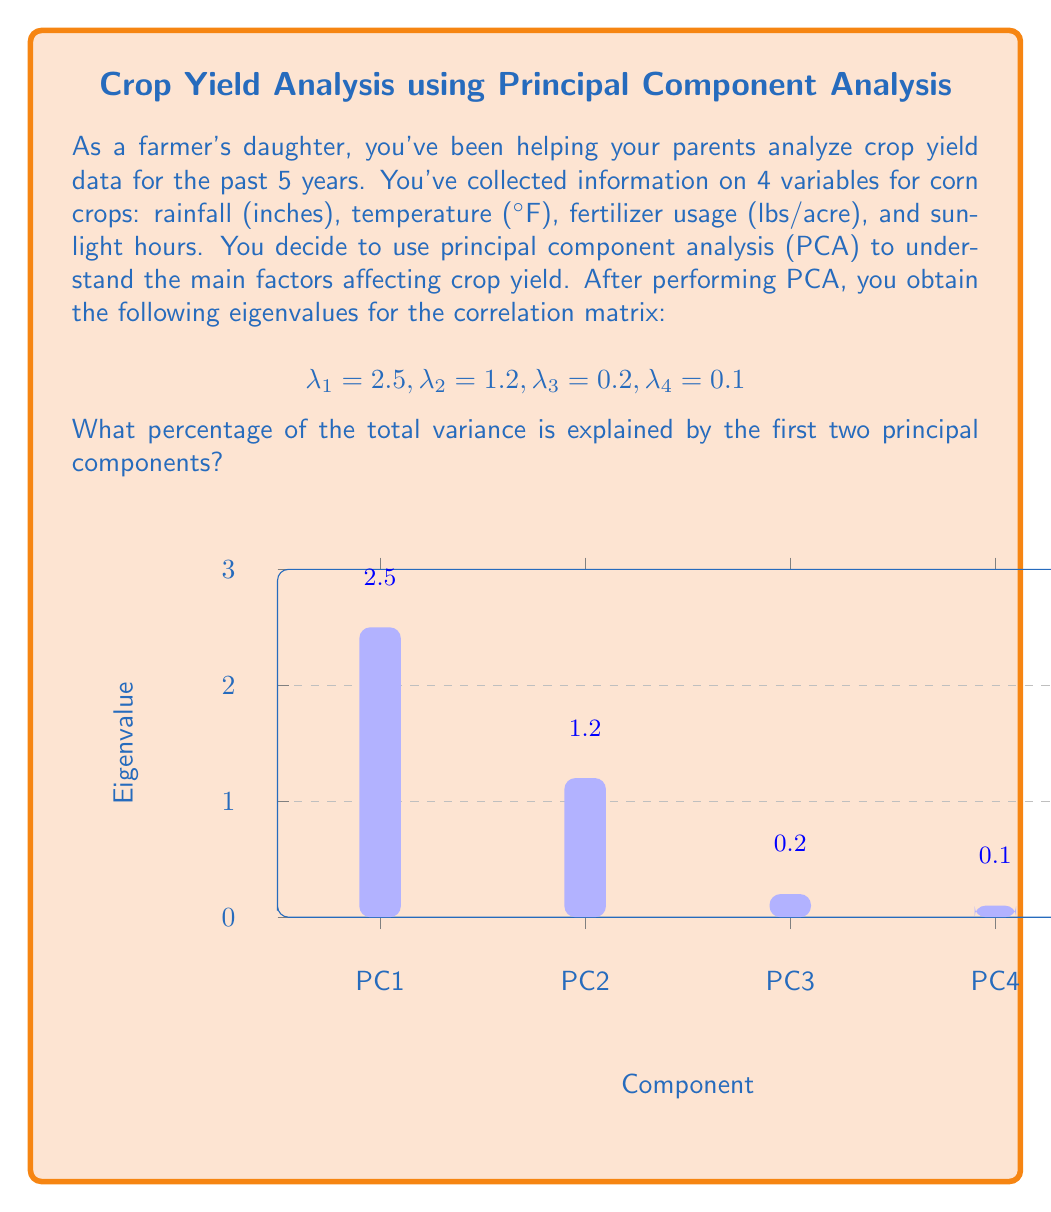Help me with this question. Let's approach this step-by-step:

1) In PCA, the eigenvalues represent the amount of variance explained by each principal component. The total variance is the sum of all eigenvalues.

2) Calculate the total variance:
   $$\text{Total Variance} = \lambda_1 + \lambda_2 + \lambda_3 + \lambda_4 = 2.5 + 1.2 + 0.2 + 0.1 = 4$$

3) The variance explained by the first two principal components is:
   $$\text{Variance (PC1 + PC2)} = \lambda_1 + \lambda_2 = 2.5 + 1.2 = 3.7$$

4) To calculate the percentage of variance explained, divide the variance of the first two components by the total variance and multiply by 100:

   $$\text{Percentage} = \frac{\text{Variance (PC1 + PC2)}}{\text{Total Variance}} \times 100\%$$
   
   $$= \frac{3.7}{4} \times 100\% = 0.925 \times 100\% = 92.5\%$$

Therefore, the first two principal components explain 92.5% of the total variance in the crop yield data.
Answer: 92.5% 